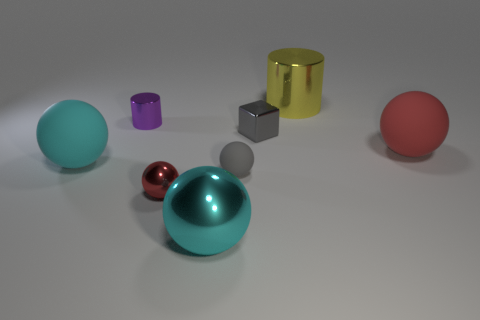Does the red matte object have the same shape as the tiny gray shiny object?
Provide a succinct answer. No. Are there fewer cyan metallic objects behind the small gray matte thing than small purple matte cylinders?
Make the answer very short. No. The matte object that is in front of the big sphere that is left of the tiny purple metallic cylinder is what color?
Your answer should be very brief. Gray. What size is the cyan thing to the left of the large metal object that is in front of the cyan sphere that is behind the small gray matte thing?
Provide a succinct answer. Large. Are there fewer red metal things behind the cyan rubber object than red rubber spheres on the right side of the big metallic ball?
Keep it short and to the point. Yes. How many tiny red objects are made of the same material as the small red ball?
Offer a very short reply. 0. There is a large sphere that is to the left of the big metal object in front of the small gray shiny thing; is there a gray object that is to the right of it?
Your response must be concise. Yes. There is a large yellow object that is the same material as the gray block; what shape is it?
Keep it short and to the point. Cylinder. Are there more tiny spheres than tiny shiny things?
Offer a very short reply. No. There is a big cyan metal thing; is its shape the same as the big rubber thing behind the cyan rubber ball?
Make the answer very short. Yes. 